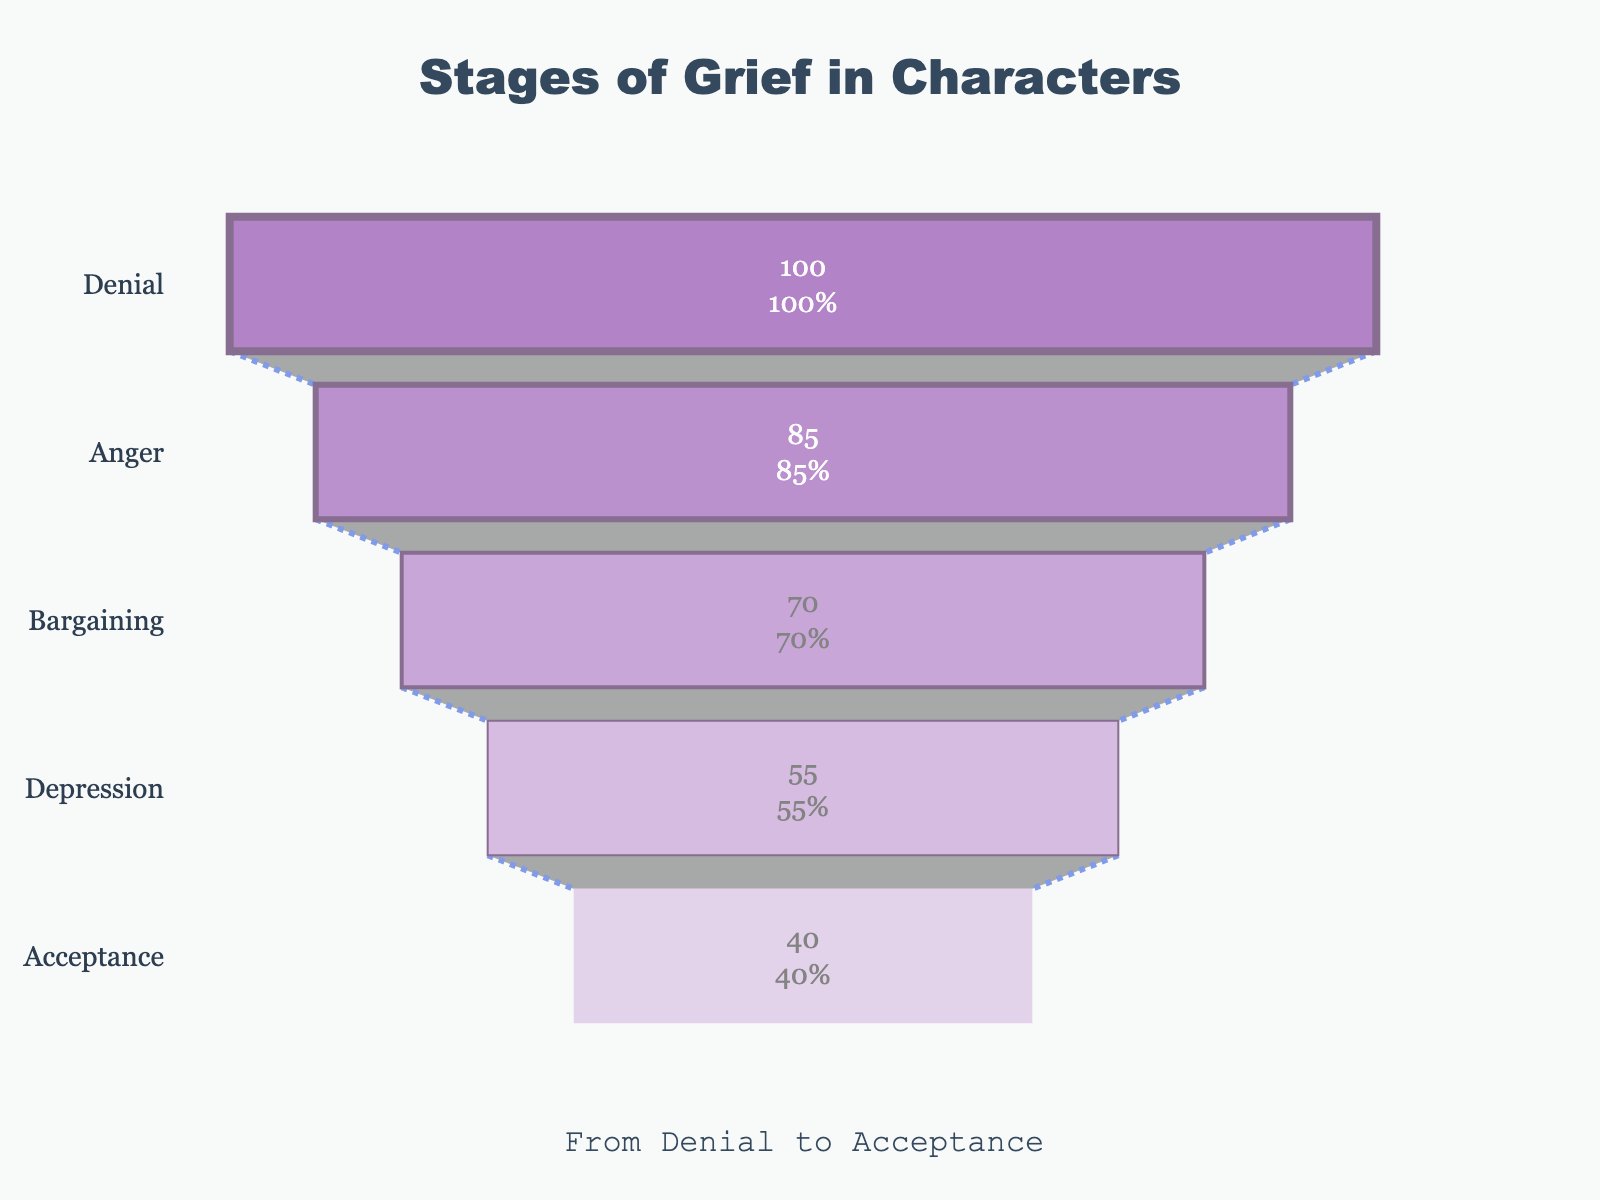Which stage of grief has the highest percentage? By looking at the funnel chart, we see that the stage "Denial" is at the top with a percentage value of 100%.
Answer: Denial What's the difference in percentage between Bargaining and Acceptance? According to the chart, Bargaining has a percentage of 70% and Acceptance has 40%. The difference is 70 - 40 = 30%.
Answer: 30% Which stage comes immediately after Anger? Based on the order of stages listed in the chart, Bargaining comes immediately after Anger.
Answer: Bargaining Which stage shows the greatest drop in percentage from the previous stage? To find the greatest drop, we check the difference between each consecutive stage: Denial to Anger (100 - 85 = 15), Anger to Bargaining (85 - 70 = 15), Bargaining to Depression (70 - 55 = 15), and Depression to Acceptance (55 - 40 = 15). All drops are equal to 15%.
Answer: All drops are equal What is the total percentage drop from Denial to Acceptance? Starting from Denial (100%) to Acceptance (40%), the total drop is 100 - 40 = 60%.
Answer: 60% What percentage of characters are still in the Denial or Anger stages? The percentage for Denial is 100%, and for Anger, it is 85%. Hence, adding them gives 100 + 85 = 185%.
Answer: 185% How does the visual color range change from Denial to Acceptance? The funnel chart uses colors ranging from dark purple for Denial to light purple for Acceptance, which becomes lighter as the stages progress.
Answer: Dark to light purple Which stage appears to have the least emotional intensity based on its percentage? By referring to the chart, Acceptance has the lowest percentage at 40%, indicating the least intensity.
Answer: Acceptance 